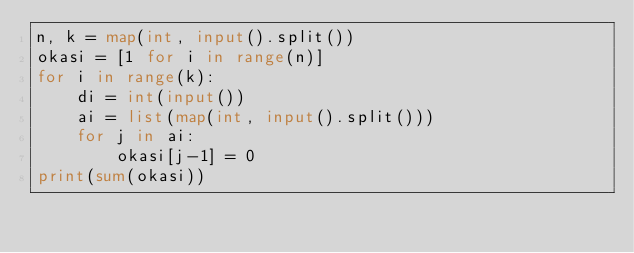<code> <loc_0><loc_0><loc_500><loc_500><_Python_>n, k = map(int, input().split())
okasi = [1 for i in range(n)]
for i in range(k):
    di = int(input())
    ai = list(map(int, input().split()))
    for j in ai:
        okasi[j-1] = 0
print(sum(okasi))</code> 